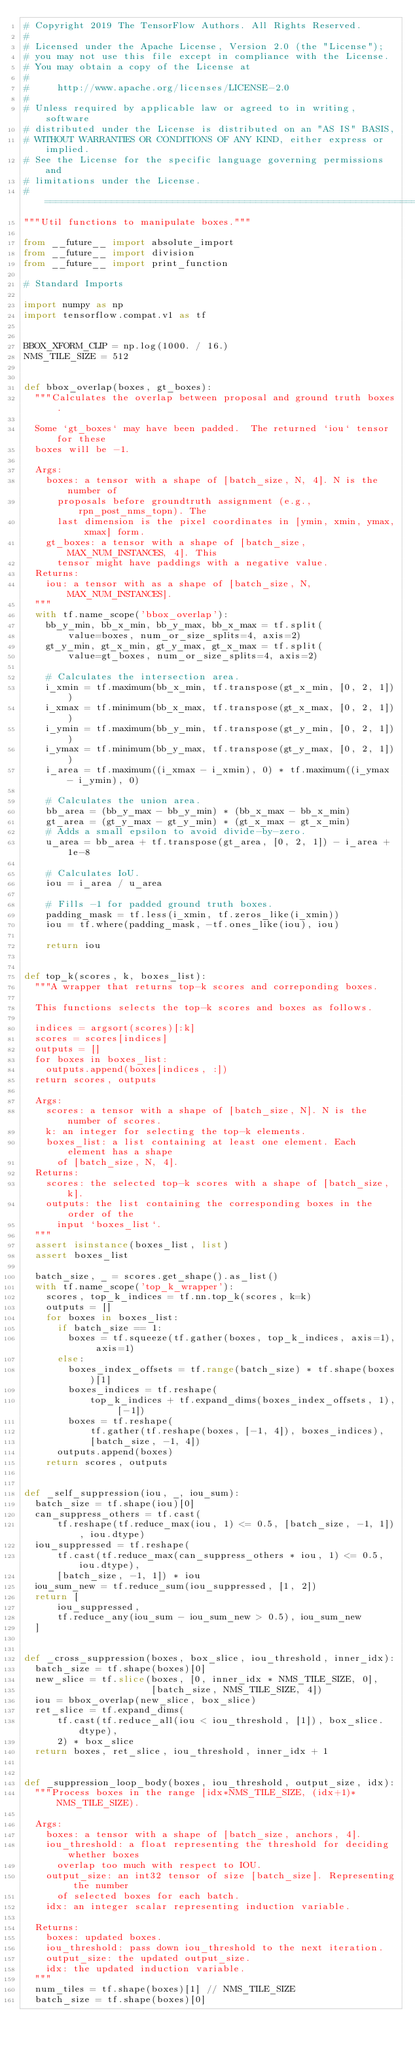<code> <loc_0><loc_0><loc_500><loc_500><_Python_># Copyright 2019 The TensorFlow Authors. All Rights Reserved.
#
# Licensed under the Apache License, Version 2.0 (the "License");
# you may not use this file except in compliance with the License.
# You may obtain a copy of the License at
#
#     http://www.apache.org/licenses/LICENSE-2.0
#
# Unless required by applicable law or agreed to in writing, software
# distributed under the License is distributed on an "AS IS" BASIS,
# WITHOUT WARRANTIES OR CONDITIONS OF ANY KIND, either express or implied.
# See the License for the specific language governing permissions and
# limitations under the License.
# ==============================================================================
"""Util functions to manipulate boxes."""

from __future__ import absolute_import
from __future__ import division
from __future__ import print_function

# Standard Imports

import numpy as np
import tensorflow.compat.v1 as tf


BBOX_XFORM_CLIP = np.log(1000. / 16.)
NMS_TILE_SIZE = 512


def bbox_overlap(boxes, gt_boxes):
  """Calculates the overlap between proposal and ground truth boxes.

  Some `gt_boxes` may have been padded.  The returned `iou` tensor for these
  boxes will be -1.

  Args:
    boxes: a tensor with a shape of [batch_size, N, 4]. N is the number of
      proposals before groundtruth assignment (e.g., rpn_post_nms_topn). The
      last dimension is the pixel coordinates in [ymin, xmin, ymax, xmax] form.
    gt_boxes: a tensor with a shape of [batch_size, MAX_NUM_INSTANCES, 4]. This
      tensor might have paddings with a negative value.
  Returns:
    iou: a tensor with as a shape of [batch_size, N, MAX_NUM_INSTANCES].
  """
  with tf.name_scope('bbox_overlap'):
    bb_y_min, bb_x_min, bb_y_max, bb_x_max = tf.split(
        value=boxes, num_or_size_splits=4, axis=2)
    gt_y_min, gt_x_min, gt_y_max, gt_x_max = tf.split(
        value=gt_boxes, num_or_size_splits=4, axis=2)

    # Calculates the intersection area.
    i_xmin = tf.maximum(bb_x_min, tf.transpose(gt_x_min, [0, 2, 1]))
    i_xmax = tf.minimum(bb_x_max, tf.transpose(gt_x_max, [0, 2, 1]))
    i_ymin = tf.maximum(bb_y_min, tf.transpose(gt_y_min, [0, 2, 1]))
    i_ymax = tf.minimum(bb_y_max, tf.transpose(gt_y_max, [0, 2, 1]))
    i_area = tf.maximum((i_xmax - i_xmin), 0) * tf.maximum((i_ymax - i_ymin), 0)

    # Calculates the union area.
    bb_area = (bb_y_max - bb_y_min) * (bb_x_max - bb_x_min)
    gt_area = (gt_y_max - gt_y_min) * (gt_x_max - gt_x_min)
    # Adds a small epsilon to avoid divide-by-zero.
    u_area = bb_area + tf.transpose(gt_area, [0, 2, 1]) - i_area + 1e-8

    # Calculates IoU.
    iou = i_area / u_area

    # Fills -1 for padded ground truth boxes.
    padding_mask = tf.less(i_xmin, tf.zeros_like(i_xmin))
    iou = tf.where(padding_mask, -tf.ones_like(iou), iou)

    return iou


def top_k(scores, k, boxes_list):
  """A wrapper that returns top-k scores and correponding boxes.

  This functions selects the top-k scores and boxes as follows.

  indices = argsort(scores)[:k]
  scores = scores[indices]
  outputs = []
  for boxes in boxes_list:
    outputs.append(boxes[indices, :])
  return scores, outputs

  Args:
    scores: a tensor with a shape of [batch_size, N]. N is the number of scores.
    k: an integer for selecting the top-k elements.
    boxes_list: a list containing at least one element. Each element has a shape
      of [batch_size, N, 4].
  Returns:
    scores: the selected top-k scores with a shape of [batch_size, k].
    outputs: the list containing the corresponding boxes in the order of the
      input `boxes_list`.
  """
  assert isinstance(boxes_list, list)
  assert boxes_list

  batch_size, _ = scores.get_shape().as_list()
  with tf.name_scope('top_k_wrapper'):
    scores, top_k_indices = tf.nn.top_k(scores, k=k)
    outputs = []
    for boxes in boxes_list:
      if batch_size == 1:
        boxes = tf.squeeze(tf.gather(boxes, top_k_indices, axis=1), axis=1)
      else:
        boxes_index_offsets = tf.range(batch_size) * tf.shape(boxes)[1]
        boxes_indices = tf.reshape(
            top_k_indices + tf.expand_dims(boxes_index_offsets, 1), [-1])
        boxes = tf.reshape(
            tf.gather(tf.reshape(boxes, [-1, 4]), boxes_indices),
            [batch_size, -1, 4])
      outputs.append(boxes)
    return scores, outputs


def _self_suppression(iou, _, iou_sum):
  batch_size = tf.shape(iou)[0]
  can_suppress_others = tf.cast(
      tf.reshape(tf.reduce_max(iou, 1) <= 0.5, [batch_size, -1, 1]), iou.dtype)
  iou_suppressed = tf.reshape(
      tf.cast(tf.reduce_max(can_suppress_others * iou, 1) <= 0.5, iou.dtype),
      [batch_size, -1, 1]) * iou
  iou_sum_new = tf.reduce_sum(iou_suppressed, [1, 2])
  return [
      iou_suppressed,
      tf.reduce_any(iou_sum - iou_sum_new > 0.5), iou_sum_new
  ]


def _cross_suppression(boxes, box_slice, iou_threshold, inner_idx):
  batch_size = tf.shape(boxes)[0]
  new_slice = tf.slice(boxes, [0, inner_idx * NMS_TILE_SIZE, 0],
                       [batch_size, NMS_TILE_SIZE, 4])
  iou = bbox_overlap(new_slice, box_slice)
  ret_slice = tf.expand_dims(
      tf.cast(tf.reduce_all(iou < iou_threshold, [1]), box_slice.dtype),
      2) * box_slice
  return boxes, ret_slice, iou_threshold, inner_idx + 1


def _suppression_loop_body(boxes, iou_threshold, output_size, idx):
  """Process boxes in the range [idx*NMS_TILE_SIZE, (idx+1)*NMS_TILE_SIZE).

  Args:
    boxes: a tensor with a shape of [batch_size, anchors, 4].
    iou_threshold: a float representing the threshold for deciding whether boxes
      overlap too much with respect to IOU.
    output_size: an int32 tensor of size [batch_size]. Representing the number
      of selected boxes for each batch.
    idx: an integer scalar representing induction variable.

  Returns:
    boxes: updated boxes.
    iou_threshold: pass down iou_threshold to the next iteration.
    output_size: the updated output_size.
    idx: the updated induction variable.
  """
  num_tiles = tf.shape(boxes)[1] // NMS_TILE_SIZE
  batch_size = tf.shape(boxes)[0]
</code> 